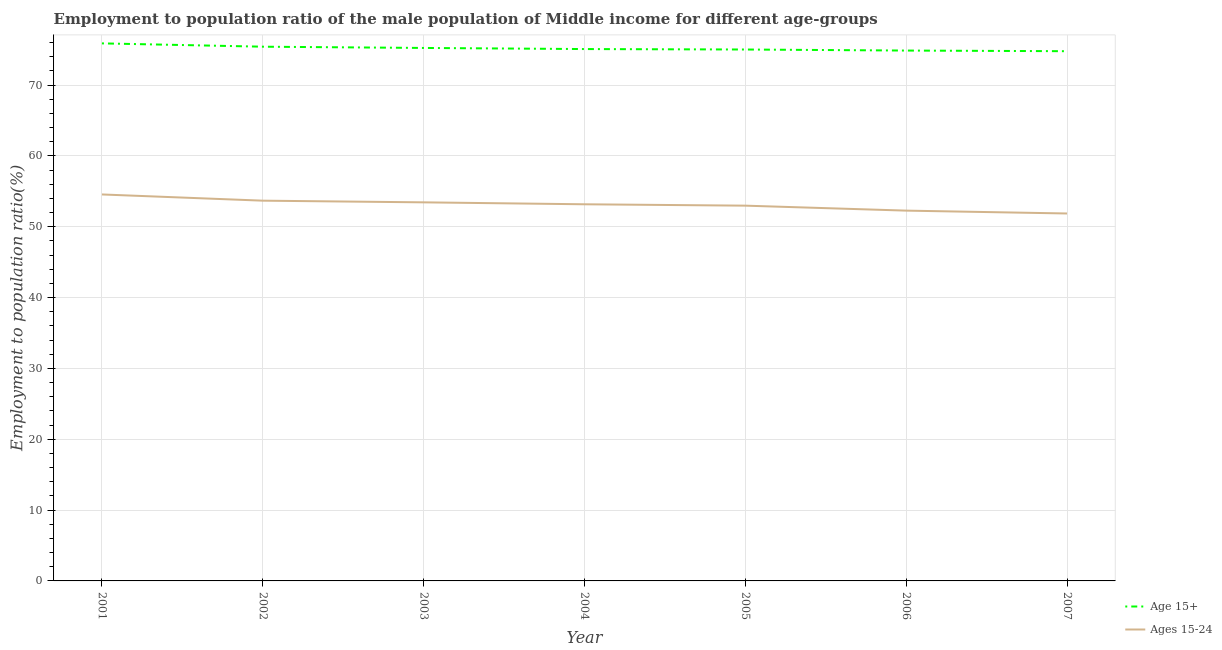What is the employment to population ratio(age 15-24) in 2004?
Provide a short and direct response. 53.16. Across all years, what is the maximum employment to population ratio(age 15+)?
Your answer should be very brief. 75.88. Across all years, what is the minimum employment to population ratio(age 15-24)?
Keep it short and to the point. 51.87. What is the total employment to population ratio(age 15+) in the graph?
Your answer should be compact. 526.23. What is the difference between the employment to population ratio(age 15+) in 2001 and that in 2002?
Offer a terse response. 0.47. What is the difference between the employment to population ratio(age 15-24) in 2004 and the employment to population ratio(age 15+) in 2001?
Your answer should be compact. -22.71. What is the average employment to population ratio(age 15-24) per year?
Provide a succinct answer. 53.13. In the year 2001, what is the difference between the employment to population ratio(age 15-24) and employment to population ratio(age 15+)?
Provide a succinct answer. -21.32. In how many years, is the employment to population ratio(age 15+) greater than 66 %?
Make the answer very short. 7. What is the ratio of the employment to population ratio(age 15+) in 2002 to that in 2006?
Your response must be concise. 1.01. What is the difference between the highest and the second highest employment to population ratio(age 15-24)?
Keep it short and to the point. 0.88. What is the difference between the highest and the lowest employment to population ratio(age 15-24)?
Give a very brief answer. 2.69. Does the employment to population ratio(age 15-24) monotonically increase over the years?
Provide a short and direct response. No. Is the employment to population ratio(age 15-24) strictly less than the employment to population ratio(age 15+) over the years?
Offer a very short reply. Yes. How many lines are there?
Offer a very short reply. 2. What is the difference between two consecutive major ticks on the Y-axis?
Offer a very short reply. 10. Does the graph contain any zero values?
Ensure brevity in your answer.  No. Does the graph contain grids?
Ensure brevity in your answer.  Yes. What is the title of the graph?
Make the answer very short. Employment to population ratio of the male population of Middle income for different age-groups. Does "Working capital" appear as one of the legend labels in the graph?
Offer a very short reply. No. What is the Employment to population ratio(%) of Age 15+ in 2001?
Your answer should be compact. 75.88. What is the Employment to population ratio(%) in Ages 15-24 in 2001?
Your answer should be very brief. 54.55. What is the Employment to population ratio(%) in Age 15+ in 2002?
Provide a short and direct response. 75.41. What is the Employment to population ratio(%) of Ages 15-24 in 2002?
Provide a short and direct response. 53.67. What is the Employment to population ratio(%) in Age 15+ in 2003?
Give a very brief answer. 75.23. What is the Employment to population ratio(%) in Ages 15-24 in 2003?
Your answer should be very brief. 53.44. What is the Employment to population ratio(%) of Age 15+ in 2004?
Provide a succinct answer. 75.07. What is the Employment to population ratio(%) of Ages 15-24 in 2004?
Offer a terse response. 53.16. What is the Employment to population ratio(%) in Age 15+ in 2005?
Provide a succinct answer. 75.01. What is the Employment to population ratio(%) in Ages 15-24 in 2005?
Give a very brief answer. 52.97. What is the Employment to population ratio(%) of Age 15+ in 2006?
Make the answer very short. 74.86. What is the Employment to population ratio(%) in Ages 15-24 in 2006?
Your answer should be compact. 52.27. What is the Employment to population ratio(%) of Age 15+ in 2007?
Make the answer very short. 74.77. What is the Employment to population ratio(%) of Ages 15-24 in 2007?
Offer a terse response. 51.87. Across all years, what is the maximum Employment to population ratio(%) in Age 15+?
Offer a terse response. 75.88. Across all years, what is the maximum Employment to population ratio(%) of Ages 15-24?
Provide a short and direct response. 54.55. Across all years, what is the minimum Employment to population ratio(%) of Age 15+?
Offer a terse response. 74.77. Across all years, what is the minimum Employment to population ratio(%) of Ages 15-24?
Your answer should be very brief. 51.87. What is the total Employment to population ratio(%) in Age 15+ in the graph?
Offer a very short reply. 526.23. What is the total Employment to population ratio(%) in Ages 15-24 in the graph?
Provide a succinct answer. 371.93. What is the difference between the Employment to population ratio(%) of Age 15+ in 2001 and that in 2002?
Your answer should be very brief. 0.47. What is the difference between the Employment to population ratio(%) of Ages 15-24 in 2001 and that in 2002?
Offer a terse response. 0.88. What is the difference between the Employment to population ratio(%) in Age 15+ in 2001 and that in 2003?
Ensure brevity in your answer.  0.64. What is the difference between the Employment to population ratio(%) in Ages 15-24 in 2001 and that in 2003?
Provide a succinct answer. 1.11. What is the difference between the Employment to population ratio(%) of Age 15+ in 2001 and that in 2004?
Your answer should be very brief. 0.8. What is the difference between the Employment to population ratio(%) of Ages 15-24 in 2001 and that in 2004?
Make the answer very short. 1.39. What is the difference between the Employment to population ratio(%) in Age 15+ in 2001 and that in 2005?
Your answer should be very brief. 0.86. What is the difference between the Employment to population ratio(%) in Ages 15-24 in 2001 and that in 2005?
Make the answer very short. 1.58. What is the difference between the Employment to population ratio(%) of Age 15+ in 2001 and that in 2006?
Your response must be concise. 1.01. What is the difference between the Employment to population ratio(%) in Ages 15-24 in 2001 and that in 2006?
Your answer should be compact. 2.28. What is the difference between the Employment to population ratio(%) of Age 15+ in 2001 and that in 2007?
Offer a terse response. 1.1. What is the difference between the Employment to population ratio(%) in Ages 15-24 in 2001 and that in 2007?
Offer a very short reply. 2.69. What is the difference between the Employment to population ratio(%) in Age 15+ in 2002 and that in 2003?
Offer a very short reply. 0.18. What is the difference between the Employment to population ratio(%) of Ages 15-24 in 2002 and that in 2003?
Make the answer very short. 0.24. What is the difference between the Employment to population ratio(%) of Age 15+ in 2002 and that in 2004?
Keep it short and to the point. 0.33. What is the difference between the Employment to population ratio(%) in Ages 15-24 in 2002 and that in 2004?
Keep it short and to the point. 0.51. What is the difference between the Employment to population ratio(%) in Age 15+ in 2002 and that in 2005?
Your answer should be compact. 0.4. What is the difference between the Employment to population ratio(%) of Ages 15-24 in 2002 and that in 2005?
Keep it short and to the point. 0.7. What is the difference between the Employment to population ratio(%) of Age 15+ in 2002 and that in 2006?
Your answer should be compact. 0.55. What is the difference between the Employment to population ratio(%) in Ages 15-24 in 2002 and that in 2006?
Your answer should be compact. 1.4. What is the difference between the Employment to population ratio(%) of Age 15+ in 2002 and that in 2007?
Offer a terse response. 0.64. What is the difference between the Employment to population ratio(%) of Ages 15-24 in 2002 and that in 2007?
Keep it short and to the point. 1.81. What is the difference between the Employment to population ratio(%) of Age 15+ in 2003 and that in 2004?
Your response must be concise. 0.16. What is the difference between the Employment to population ratio(%) in Ages 15-24 in 2003 and that in 2004?
Provide a succinct answer. 0.27. What is the difference between the Employment to population ratio(%) of Age 15+ in 2003 and that in 2005?
Offer a very short reply. 0.22. What is the difference between the Employment to population ratio(%) of Ages 15-24 in 2003 and that in 2005?
Your response must be concise. 0.47. What is the difference between the Employment to population ratio(%) of Age 15+ in 2003 and that in 2006?
Your answer should be very brief. 0.37. What is the difference between the Employment to population ratio(%) of Ages 15-24 in 2003 and that in 2006?
Offer a very short reply. 1.17. What is the difference between the Employment to population ratio(%) in Age 15+ in 2003 and that in 2007?
Your answer should be very brief. 0.46. What is the difference between the Employment to population ratio(%) in Ages 15-24 in 2003 and that in 2007?
Keep it short and to the point. 1.57. What is the difference between the Employment to population ratio(%) in Age 15+ in 2004 and that in 2005?
Ensure brevity in your answer.  0.06. What is the difference between the Employment to population ratio(%) in Ages 15-24 in 2004 and that in 2005?
Ensure brevity in your answer.  0.19. What is the difference between the Employment to population ratio(%) in Age 15+ in 2004 and that in 2006?
Provide a succinct answer. 0.21. What is the difference between the Employment to population ratio(%) of Ages 15-24 in 2004 and that in 2006?
Your response must be concise. 0.9. What is the difference between the Employment to population ratio(%) in Age 15+ in 2004 and that in 2007?
Offer a very short reply. 0.3. What is the difference between the Employment to population ratio(%) of Ages 15-24 in 2004 and that in 2007?
Ensure brevity in your answer.  1.3. What is the difference between the Employment to population ratio(%) of Age 15+ in 2005 and that in 2006?
Keep it short and to the point. 0.15. What is the difference between the Employment to population ratio(%) of Ages 15-24 in 2005 and that in 2006?
Keep it short and to the point. 0.7. What is the difference between the Employment to population ratio(%) in Age 15+ in 2005 and that in 2007?
Offer a terse response. 0.24. What is the difference between the Employment to population ratio(%) of Ages 15-24 in 2005 and that in 2007?
Provide a short and direct response. 1.1. What is the difference between the Employment to population ratio(%) of Age 15+ in 2006 and that in 2007?
Provide a short and direct response. 0.09. What is the difference between the Employment to population ratio(%) of Ages 15-24 in 2006 and that in 2007?
Your answer should be very brief. 0.4. What is the difference between the Employment to population ratio(%) of Age 15+ in 2001 and the Employment to population ratio(%) of Ages 15-24 in 2002?
Provide a short and direct response. 22.2. What is the difference between the Employment to population ratio(%) in Age 15+ in 2001 and the Employment to population ratio(%) in Ages 15-24 in 2003?
Provide a succinct answer. 22.44. What is the difference between the Employment to population ratio(%) in Age 15+ in 2001 and the Employment to population ratio(%) in Ages 15-24 in 2004?
Offer a terse response. 22.71. What is the difference between the Employment to population ratio(%) of Age 15+ in 2001 and the Employment to population ratio(%) of Ages 15-24 in 2005?
Your response must be concise. 22.91. What is the difference between the Employment to population ratio(%) of Age 15+ in 2001 and the Employment to population ratio(%) of Ages 15-24 in 2006?
Offer a terse response. 23.61. What is the difference between the Employment to population ratio(%) of Age 15+ in 2001 and the Employment to population ratio(%) of Ages 15-24 in 2007?
Offer a terse response. 24.01. What is the difference between the Employment to population ratio(%) in Age 15+ in 2002 and the Employment to population ratio(%) in Ages 15-24 in 2003?
Provide a succinct answer. 21.97. What is the difference between the Employment to population ratio(%) in Age 15+ in 2002 and the Employment to population ratio(%) in Ages 15-24 in 2004?
Your answer should be very brief. 22.24. What is the difference between the Employment to population ratio(%) of Age 15+ in 2002 and the Employment to population ratio(%) of Ages 15-24 in 2005?
Ensure brevity in your answer.  22.44. What is the difference between the Employment to population ratio(%) of Age 15+ in 2002 and the Employment to population ratio(%) of Ages 15-24 in 2006?
Keep it short and to the point. 23.14. What is the difference between the Employment to population ratio(%) of Age 15+ in 2002 and the Employment to population ratio(%) of Ages 15-24 in 2007?
Your response must be concise. 23.54. What is the difference between the Employment to population ratio(%) in Age 15+ in 2003 and the Employment to population ratio(%) in Ages 15-24 in 2004?
Provide a succinct answer. 22.07. What is the difference between the Employment to population ratio(%) of Age 15+ in 2003 and the Employment to population ratio(%) of Ages 15-24 in 2005?
Keep it short and to the point. 22.26. What is the difference between the Employment to population ratio(%) in Age 15+ in 2003 and the Employment to population ratio(%) in Ages 15-24 in 2006?
Provide a short and direct response. 22.96. What is the difference between the Employment to population ratio(%) of Age 15+ in 2003 and the Employment to population ratio(%) of Ages 15-24 in 2007?
Provide a succinct answer. 23.37. What is the difference between the Employment to population ratio(%) of Age 15+ in 2004 and the Employment to population ratio(%) of Ages 15-24 in 2005?
Keep it short and to the point. 22.11. What is the difference between the Employment to population ratio(%) in Age 15+ in 2004 and the Employment to population ratio(%) in Ages 15-24 in 2006?
Your answer should be compact. 22.81. What is the difference between the Employment to population ratio(%) of Age 15+ in 2004 and the Employment to population ratio(%) of Ages 15-24 in 2007?
Provide a succinct answer. 23.21. What is the difference between the Employment to population ratio(%) of Age 15+ in 2005 and the Employment to population ratio(%) of Ages 15-24 in 2006?
Keep it short and to the point. 22.74. What is the difference between the Employment to population ratio(%) in Age 15+ in 2005 and the Employment to population ratio(%) in Ages 15-24 in 2007?
Offer a terse response. 23.14. What is the difference between the Employment to population ratio(%) of Age 15+ in 2006 and the Employment to population ratio(%) of Ages 15-24 in 2007?
Offer a very short reply. 23. What is the average Employment to population ratio(%) of Age 15+ per year?
Make the answer very short. 75.18. What is the average Employment to population ratio(%) in Ages 15-24 per year?
Provide a short and direct response. 53.13. In the year 2001, what is the difference between the Employment to population ratio(%) of Age 15+ and Employment to population ratio(%) of Ages 15-24?
Offer a very short reply. 21.32. In the year 2002, what is the difference between the Employment to population ratio(%) in Age 15+ and Employment to population ratio(%) in Ages 15-24?
Your answer should be very brief. 21.74. In the year 2003, what is the difference between the Employment to population ratio(%) of Age 15+ and Employment to population ratio(%) of Ages 15-24?
Ensure brevity in your answer.  21.79. In the year 2004, what is the difference between the Employment to population ratio(%) in Age 15+ and Employment to population ratio(%) in Ages 15-24?
Your answer should be very brief. 21.91. In the year 2005, what is the difference between the Employment to population ratio(%) in Age 15+ and Employment to population ratio(%) in Ages 15-24?
Offer a terse response. 22.04. In the year 2006, what is the difference between the Employment to population ratio(%) of Age 15+ and Employment to population ratio(%) of Ages 15-24?
Provide a short and direct response. 22.59. In the year 2007, what is the difference between the Employment to population ratio(%) in Age 15+ and Employment to population ratio(%) in Ages 15-24?
Provide a succinct answer. 22.91. What is the ratio of the Employment to population ratio(%) in Age 15+ in 2001 to that in 2002?
Give a very brief answer. 1.01. What is the ratio of the Employment to population ratio(%) of Ages 15-24 in 2001 to that in 2002?
Offer a very short reply. 1.02. What is the ratio of the Employment to population ratio(%) in Age 15+ in 2001 to that in 2003?
Provide a short and direct response. 1.01. What is the ratio of the Employment to population ratio(%) in Ages 15-24 in 2001 to that in 2003?
Keep it short and to the point. 1.02. What is the ratio of the Employment to population ratio(%) of Age 15+ in 2001 to that in 2004?
Provide a succinct answer. 1.01. What is the ratio of the Employment to population ratio(%) of Ages 15-24 in 2001 to that in 2004?
Keep it short and to the point. 1.03. What is the ratio of the Employment to population ratio(%) of Age 15+ in 2001 to that in 2005?
Provide a succinct answer. 1.01. What is the ratio of the Employment to population ratio(%) of Ages 15-24 in 2001 to that in 2005?
Ensure brevity in your answer.  1.03. What is the ratio of the Employment to population ratio(%) in Age 15+ in 2001 to that in 2006?
Ensure brevity in your answer.  1.01. What is the ratio of the Employment to population ratio(%) in Ages 15-24 in 2001 to that in 2006?
Provide a short and direct response. 1.04. What is the ratio of the Employment to population ratio(%) in Age 15+ in 2001 to that in 2007?
Your answer should be compact. 1.01. What is the ratio of the Employment to population ratio(%) of Ages 15-24 in 2001 to that in 2007?
Offer a very short reply. 1.05. What is the ratio of the Employment to population ratio(%) in Age 15+ in 2002 to that in 2003?
Give a very brief answer. 1. What is the ratio of the Employment to population ratio(%) in Ages 15-24 in 2002 to that in 2004?
Make the answer very short. 1.01. What is the ratio of the Employment to population ratio(%) in Ages 15-24 in 2002 to that in 2005?
Give a very brief answer. 1.01. What is the ratio of the Employment to population ratio(%) of Age 15+ in 2002 to that in 2006?
Your answer should be very brief. 1.01. What is the ratio of the Employment to population ratio(%) in Ages 15-24 in 2002 to that in 2006?
Give a very brief answer. 1.03. What is the ratio of the Employment to population ratio(%) of Age 15+ in 2002 to that in 2007?
Your response must be concise. 1.01. What is the ratio of the Employment to population ratio(%) of Ages 15-24 in 2002 to that in 2007?
Provide a succinct answer. 1.03. What is the ratio of the Employment to population ratio(%) in Age 15+ in 2003 to that in 2004?
Your response must be concise. 1. What is the ratio of the Employment to population ratio(%) of Ages 15-24 in 2003 to that in 2005?
Offer a terse response. 1.01. What is the ratio of the Employment to population ratio(%) of Ages 15-24 in 2003 to that in 2006?
Keep it short and to the point. 1.02. What is the ratio of the Employment to population ratio(%) in Age 15+ in 2003 to that in 2007?
Keep it short and to the point. 1.01. What is the ratio of the Employment to population ratio(%) of Ages 15-24 in 2003 to that in 2007?
Ensure brevity in your answer.  1.03. What is the ratio of the Employment to population ratio(%) in Ages 15-24 in 2004 to that in 2005?
Your answer should be compact. 1. What is the ratio of the Employment to population ratio(%) in Ages 15-24 in 2004 to that in 2006?
Offer a terse response. 1.02. What is the ratio of the Employment to population ratio(%) in Age 15+ in 2004 to that in 2007?
Provide a short and direct response. 1. What is the ratio of the Employment to population ratio(%) in Age 15+ in 2005 to that in 2006?
Your response must be concise. 1. What is the ratio of the Employment to population ratio(%) of Ages 15-24 in 2005 to that in 2006?
Give a very brief answer. 1.01. What is the ratio of the Employment to population ratio(%) of Age 15+ in 2005 to that in 2007?
Give a very brief answer. 1. What is the ratio of the Employment to population ratio(%) of Ages 15-24 in 2005 to that in 2007?
Provide a short and direct response. 1.02. What is the difference between the highest and the second highest Employment to population ratio(%) in Age 15+?
Make the answer very short. 0.47. What is the difference between the highest and the second highest Employment to population ratio(%) in Ages 15-24?
Your response must be concise. 0.88. What is the difference between the highest and the lowest Employment to population ratio(%) in Age 15+?
Provide a short and direct response. 1.1. What is the difference between the highest and the lowest Employment to population ratio(%) of Ages 15-24?
Make the answer very short. 2.69. 